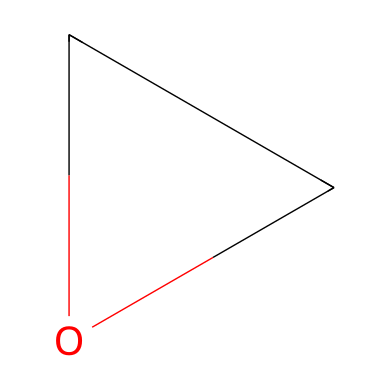What is the molecular formula of ethylene oxide? The structure depicts two carbon atoms and one oxygen atom, which corresponds to the molecular formula of ethylene oxide, represented as C2H4O.
Answer: C2H4O How many total atoms are present in the ethylene oxide molecule? The molecule consists of 2 carbon atoms, 4 hydrogen atoms, and 1 oxygen atom, summing up to a total of 7 atoms.
Answer: 7 How many bonds are present in ethylene oxide? The structure suggests there are 4 single bonds (C-H) and 1 bond (C-O), making a total of 5 bonds in the ethylene oxide molecule.
Answer: 5 Is ethylene oxide a gas at room temperature? Given that ethylene oxide has a low boiling point of about 10.5 °C, it is primarily found in a gaseous state at room temperature.
Answer: Yes How does the presence of the oxygen atom affect the reactivity of ethylene oxide? The oxygen atom introduces polarity and brings reactive characteristics to the compound, allowing it to react readily with a variety of nucleophiles, making it effective as a sterilizing agent.
Answer: Increased reactivity What type of chemical reaction does ethylene oxide typically undergo for sterilization? Ethylene oxide primarily undergoes alkylation reactions, which involve the transfer of an ethyl group to the target microbial DNA or proteins, leading to their inactivation.
Answer: Alkylation Why is ethylene oxide preferred for sterilizing heat-sensitive medical equipment? Ethylene oxide gas can penetrate complex instruments and materials without the need for high temperatures, making it suitable for heat-sensitive items that could be damaged by traditional sterilization methods.
Answer: Heat-sensitive sterilization 